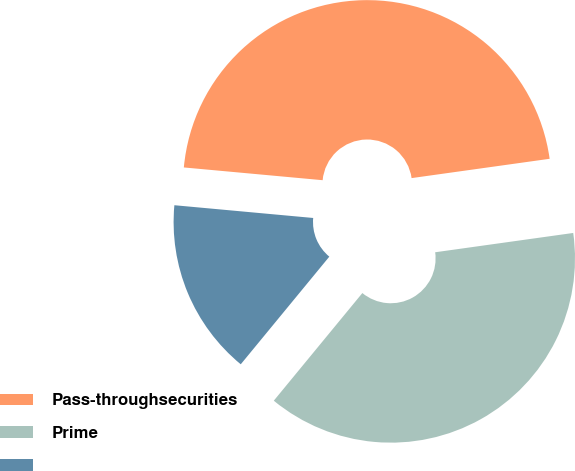Convert chart to OTSL. <chart><loc_0><loc_0><loc_500><loc_500><pie_chart><fcel>Pass-throughsecurities<fcel>Prime<fcel>Unnamed: 2<nl><fcel>46.33%<fcel>38.17%<fcel>15.5%<nl></chart> 